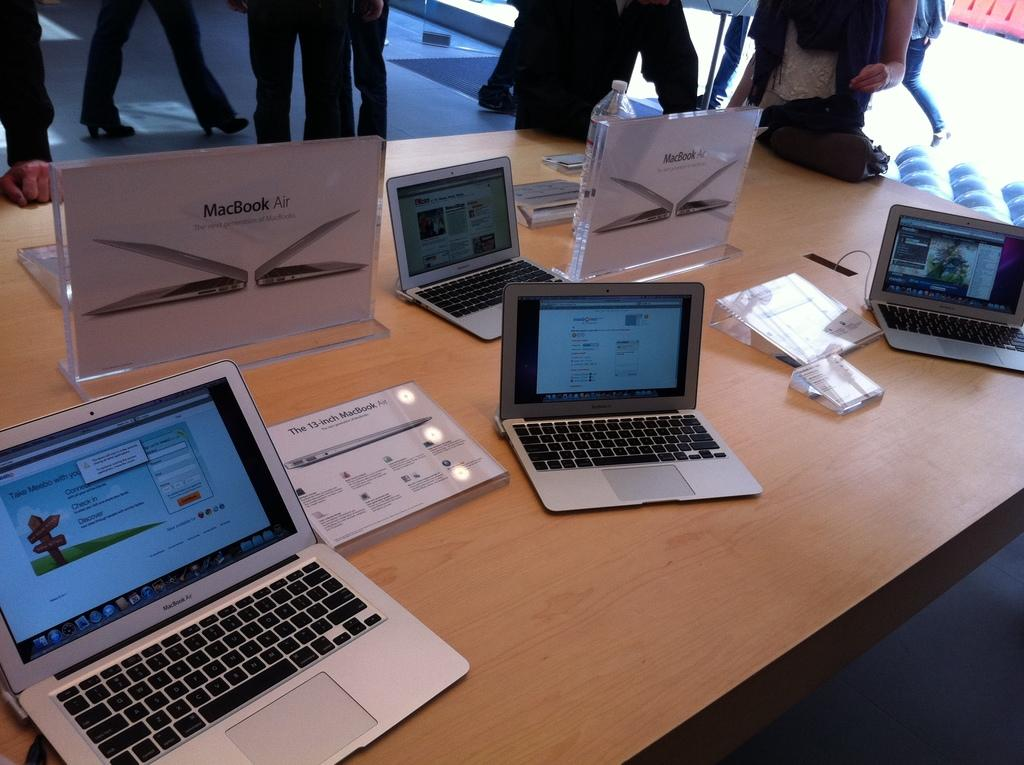<image>
Describe the image concisely. Multiple MacBook Air laptops are displayed on a wooden table. 